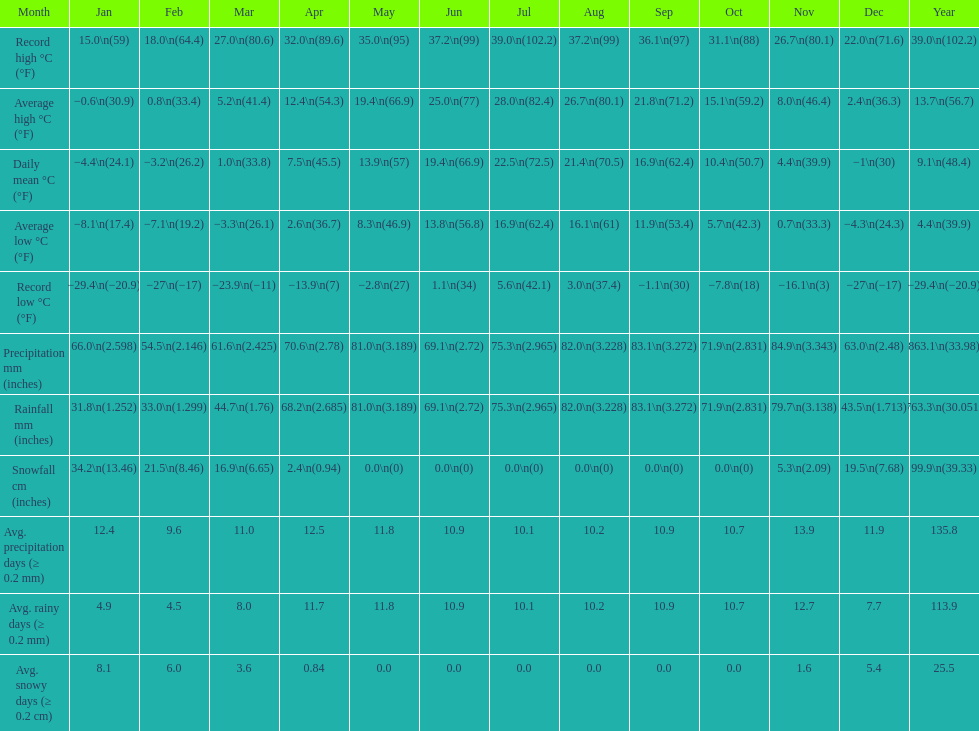8 degrees and the record lowest - September. 